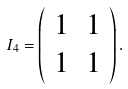Convert formula to latex. <formula><loc_0><loc_0><loc_500><loc_500>{ I _ { 4 } } = \left ( \begin{array} { l l } 1 & 1 \\ 1 & 1 \end{array} \right ) .</formula> 